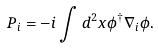<formula> <loc_0><loc_0><loc_500><loc_500>P _ { i } = - i \int d ^ { 2 } x \phi ^ { \dagger } \nabla _ { i } \phi .</formula> 